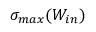<formula> <loc_0><loc_0><loc_500><loc_500>\sigma _ { \max } ( W _ { i n } )</formula> 